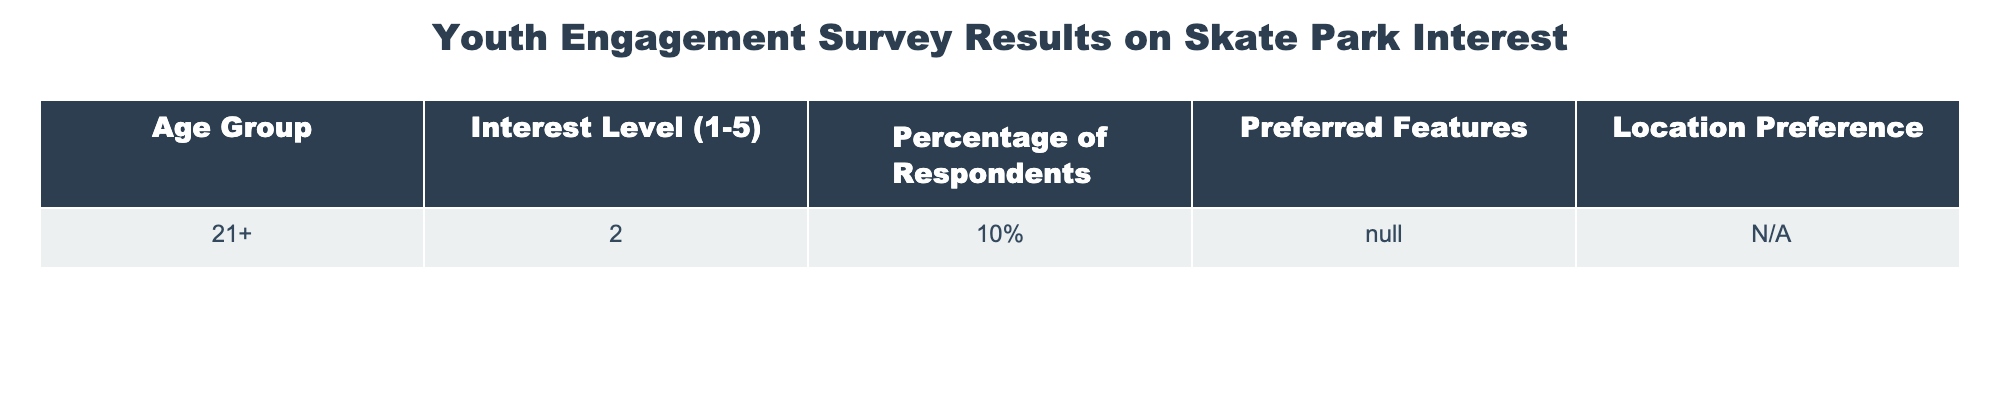What is the interest level of the respondents aged 21 and above? The table indicates that the interest level for the age group 21+ is rated as 2.
Answer: 2 What percentage of respondents aged 21 and above showed interest in the skate park? The table states that 10% of respondents in the 21+ age group expressed interest.
Answer: 10% Is there any specific location preference indicated for the respondents aged 21 and above? The table shows "N/A" for location preference for the 21+ age group, indicating no preference provided.
Answer: No What is the total number of respondents who provided an interest level for the age group 21+? The table only provides percentage data and not the total number of respondents, but it implies that there were respondents in this age group. Without more information, the total cannot be determined from the table.
Answer: Cannot determine If we consider the interest levels overall, what could be inferred about the need for a skate park among the respondents? Since the interest level rated as 2 corresponds to a low interest, and only 10% showed any interest, it suggests there may be insufficient demand for a skate park among this age group.
Answer: Low demand 